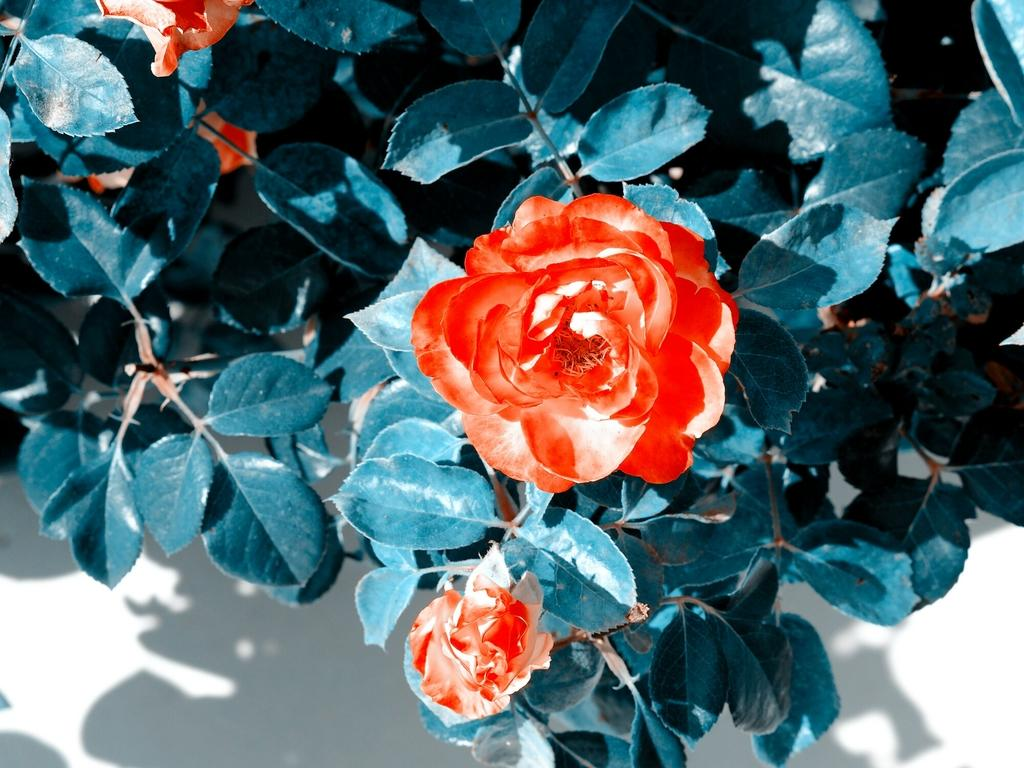What type of living organisms can be seen in the image? Plants and flowers can be seen in the image. Can you describe the flowers in the image? Yes, there are flowers in the image. What type of iron object can be seen in the image? There is no iron object present in the image. Can you tell me how many mountains are visible in the image? There are no mountains visible in the image. 